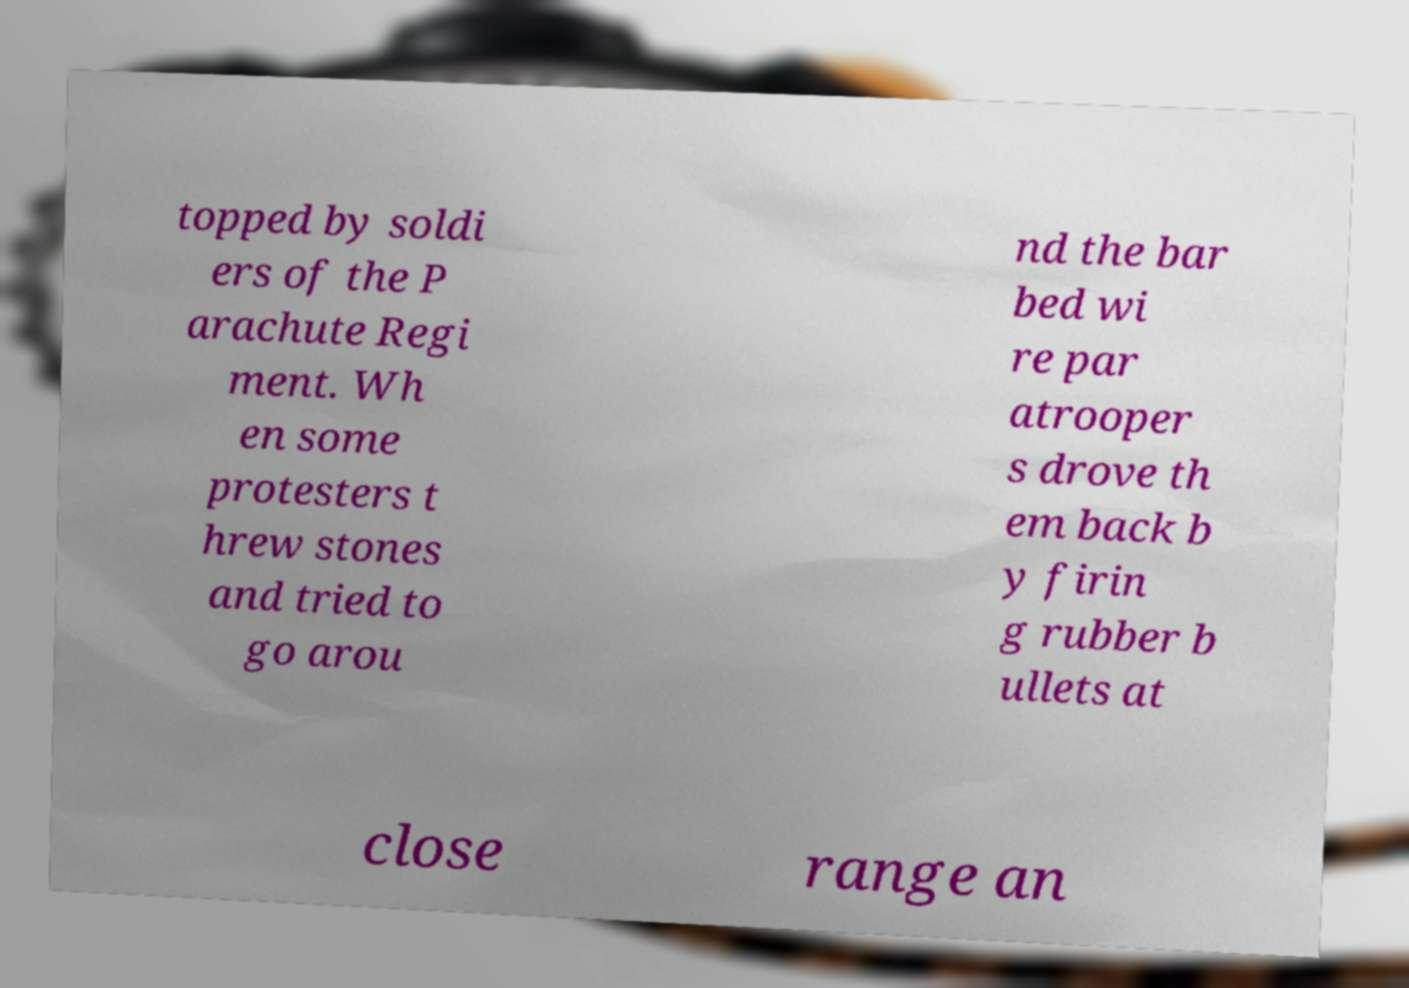Could you assist in decoding the text presented in this image and type it out clearly? topped by soldi ers of the P arachute Regi ment. Wh en some protesters t hrew stones and tried to go arou nd the bar bed wi re par atrooper s drove th em back b y firin g rubber b ullets at close range an 